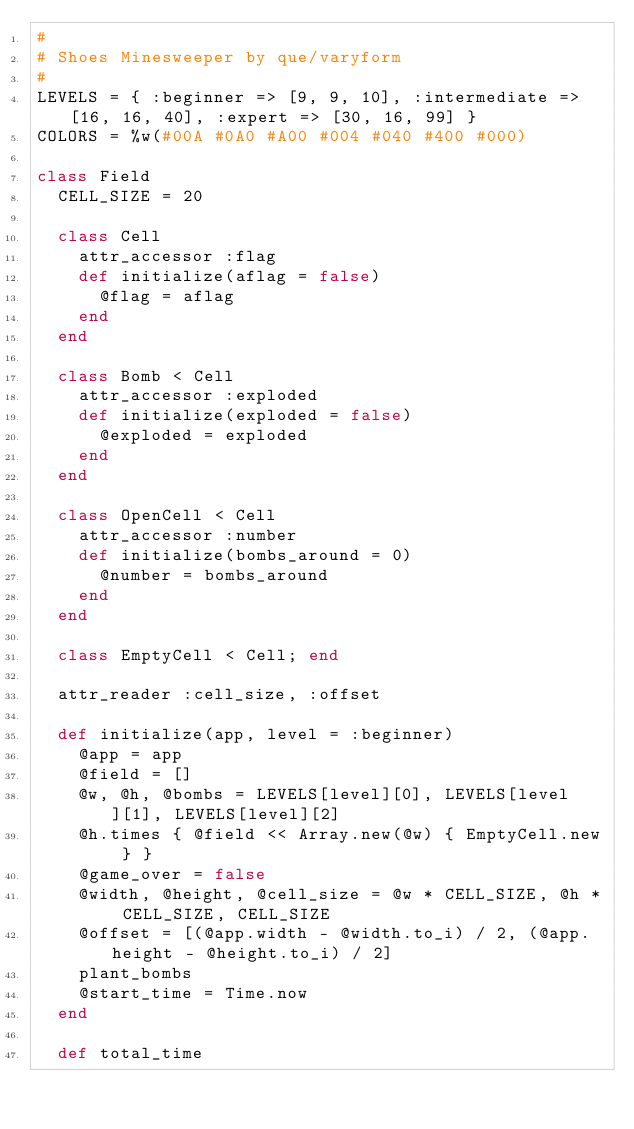Convert code to text. <code><loc_0><loc_0><loc_500><loc_500><_Ruby_>#
# Shoes Minesweeper by que/varyform
#
LEVELS = { :beginner => [9, 9, 10], :intermediate => [16, 16, 40], :expert => [30, 16, 99] }
COLORS = %w(#00A #0A0 #A00 #004 #040 #400 #000)

class Field
  CELL_SIZE = 20
  
  class Cell
    attr_accessor :flag
    def initialize(aflag = false)
      @flag = aflag
    end
  end
  
  class Bomb < Cell
    attr_accessor :exploded
    def initialize(exploded = false)
      @exploded = exploded
    end
  end
  
  class OpenCell < Cell
    attr_accessor :number
    def initialize(bombs_around = 0)
      @number = bombs_around
    end
  end
  
  class EmptyCell < Cell; end
  
  attr_reader :cell_size, :offset
  
  def initialize(app, level = :beginner)
    @app = app
    @field = []
    @w, @h, @bombs = LEVELS[level][0], LEVELS[level][1], LEVELS[level][2]
    @h.times { @field << Array.new(@w) { EmptyCell.new } }
    @game_over = false
    @width, @height, @cell_size = @w * CELL_SIZE, @h * CELL_SIZE, CELL_SIZE
    @offset = [(@app.width - @width.to_i) / 2, (@app.height - @height.to_i) / 2]
    plant_bombs
    @start_time = Time.now
  end
  
  def total_time</code> 